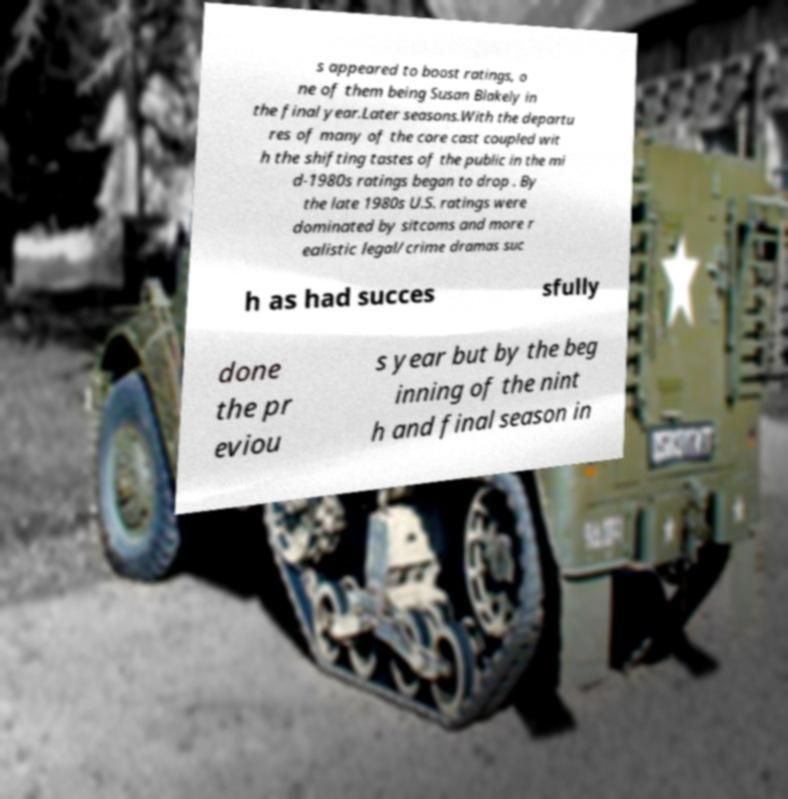Can you read and provide the text displayed in the image?This photo seems to have some interesting text. Can you extract and type it out for me? s appeared to boost ratings, o ne of them being Susan Blakely in the final year.Later seasons.With the departu res of many of the core cast coupled wit h the shifting tastes of the public in the mi d-1980s ratings began to drop . By the late 1980s U.S. ratings were dominated by sitcoms and more r ealistic legal/crime dramas suc h as had succes sfully done the pr eviou s year but by the beg inning of the nint h and final season in 